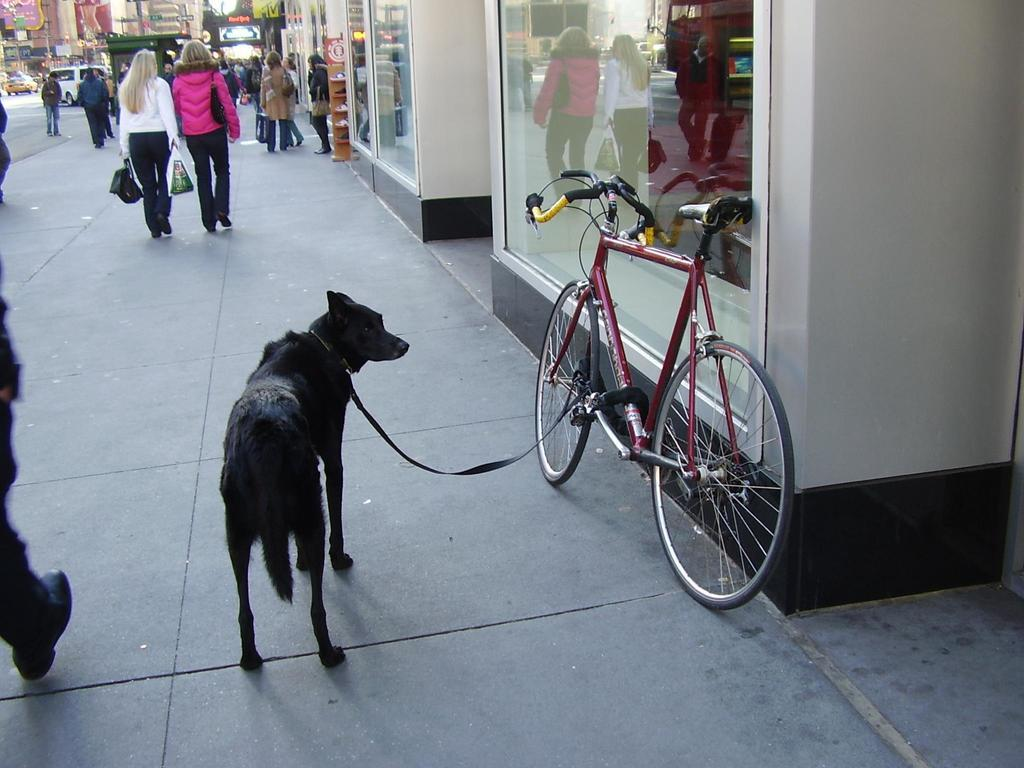What animal can be seen in the image? There is a dog in the image. How is the dog restrained in the image? The dog is tied to a cycle with a chain. What type of structures are visible in the image? There are buildings visible in the image. Who else is present in the image besides the dog? There are people present in the image. What else can be seen in the image besides the dog and people? Vehicles are present in the image. What note is the dog playing on the guitar in the image? There is no guitar or note being played in the image; the dog is tied to a cycle with a chain. 